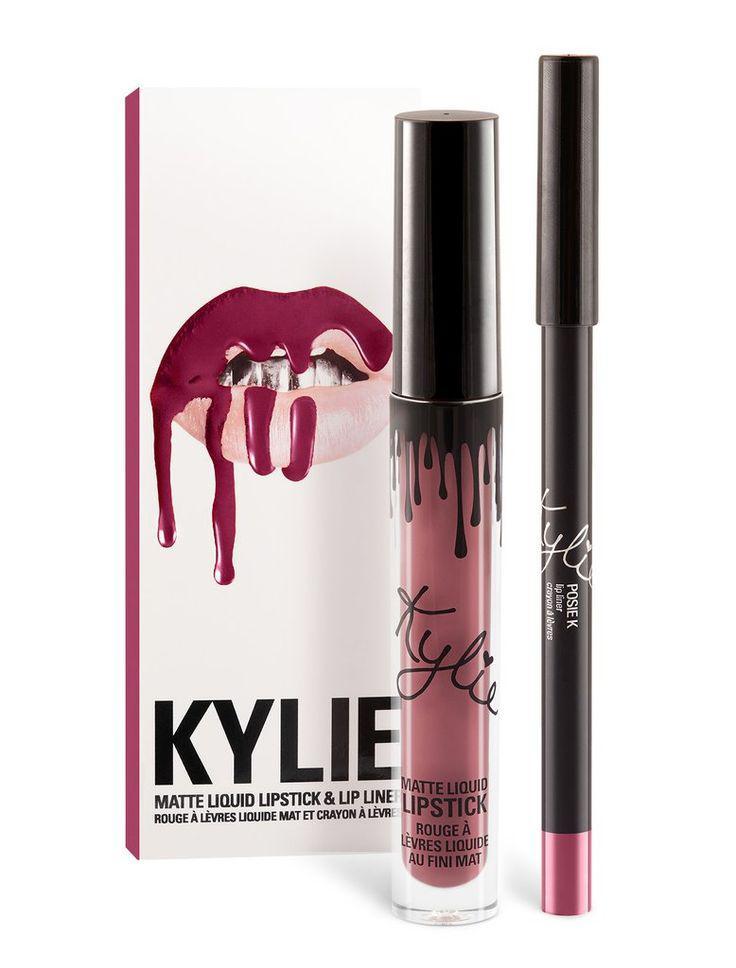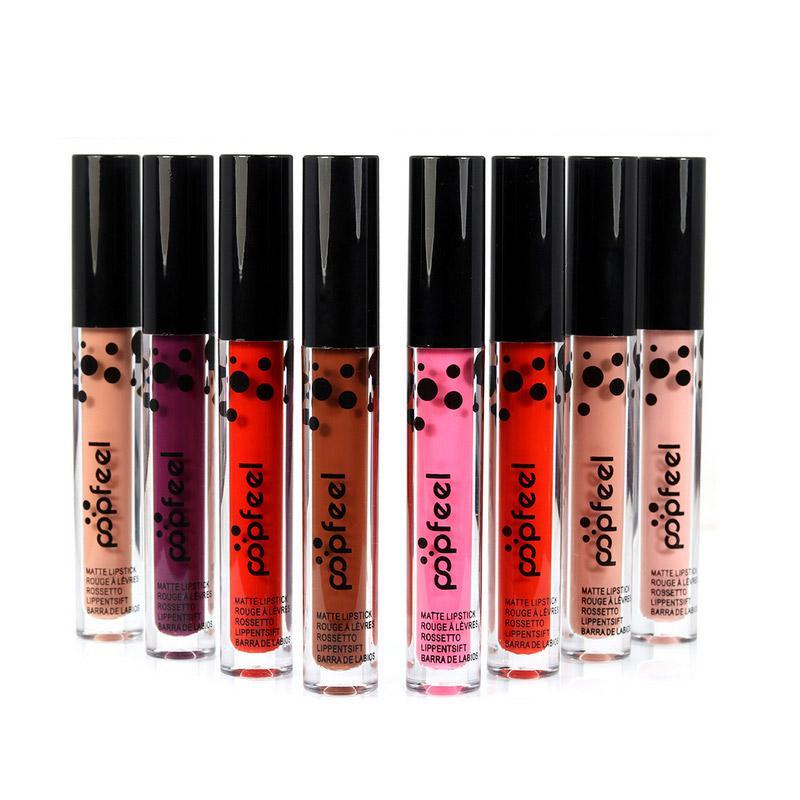The first image is the image on the left, the second image is the image on the right. Evaluate the accuracy of this statement regarding the images: "At least one lipstick has an odd phallus shape.". Is it true? Answer yes or no. No. 